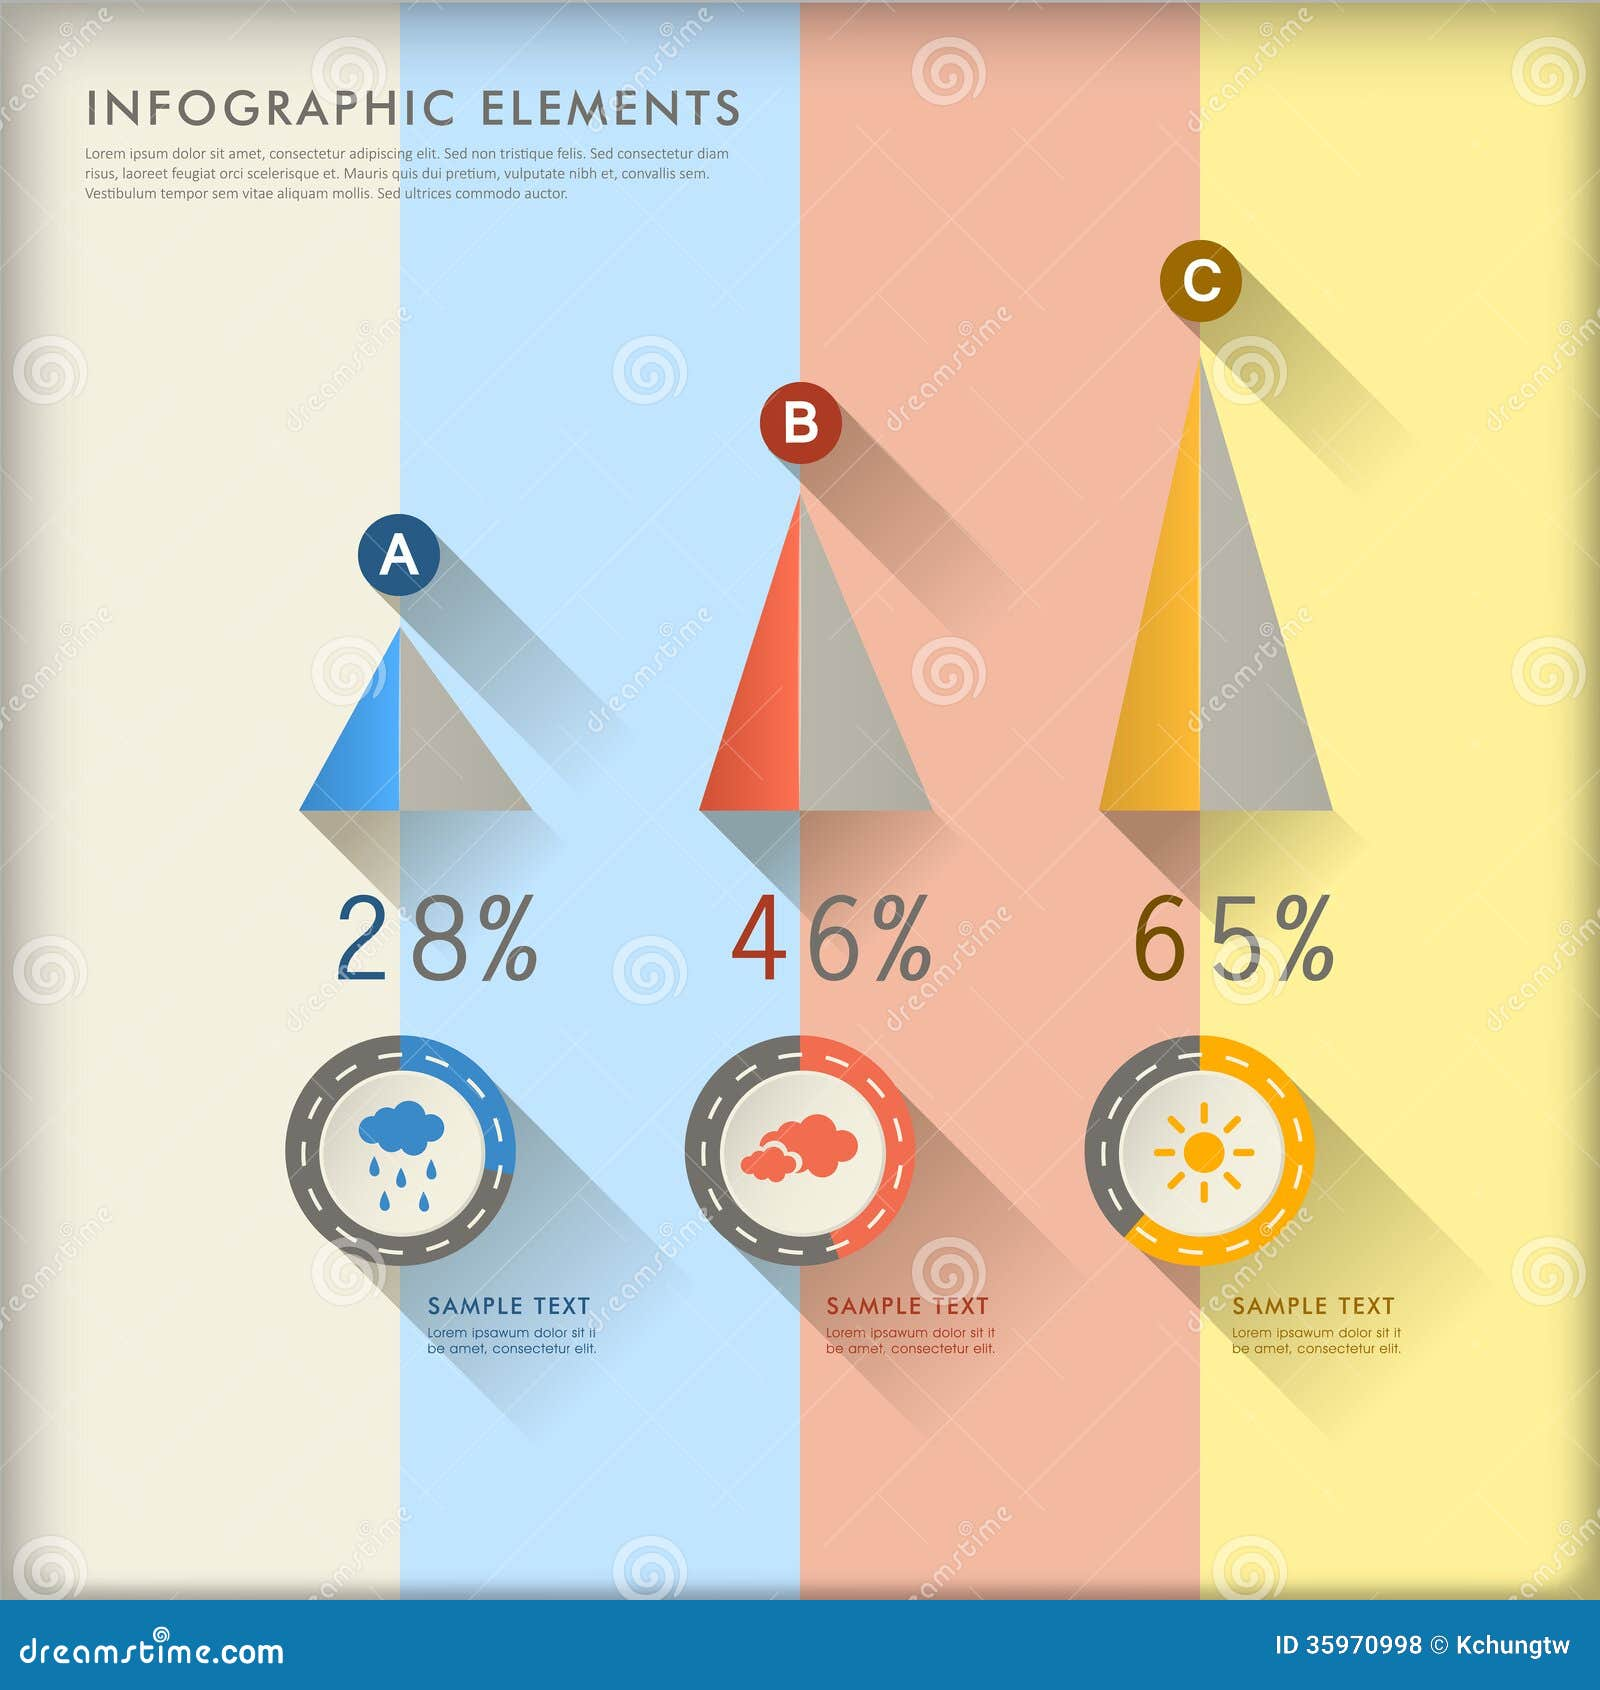Based on the design elements and percentages presented, what might the infographic be attempting to convey about the relationship between the icons and the corresponding percentages, and how does the visual design support this message? The infographic appears to illustrate a quantitative comparison among three categories, each signified by a distinct icon and corresponding percentage. The rain cloud, red cloud, and sun seem to represent different weather conditions, possibly rain, overcast, and sunny, with the percentages suggesting their relative frequencies or significance. The infographic uses an ascending order of pyramid heights and corresponding percentages to emphasize a progression from left to right, visually representing an increase. The color coding and distinct icons help to differentiate between the categories, while the numerical percentages provide a clear, quick reference for comparison. The minimalistic design ensures that the information is easily digestible and visually engaging, allowing viewers to grasp the data at a glance. 